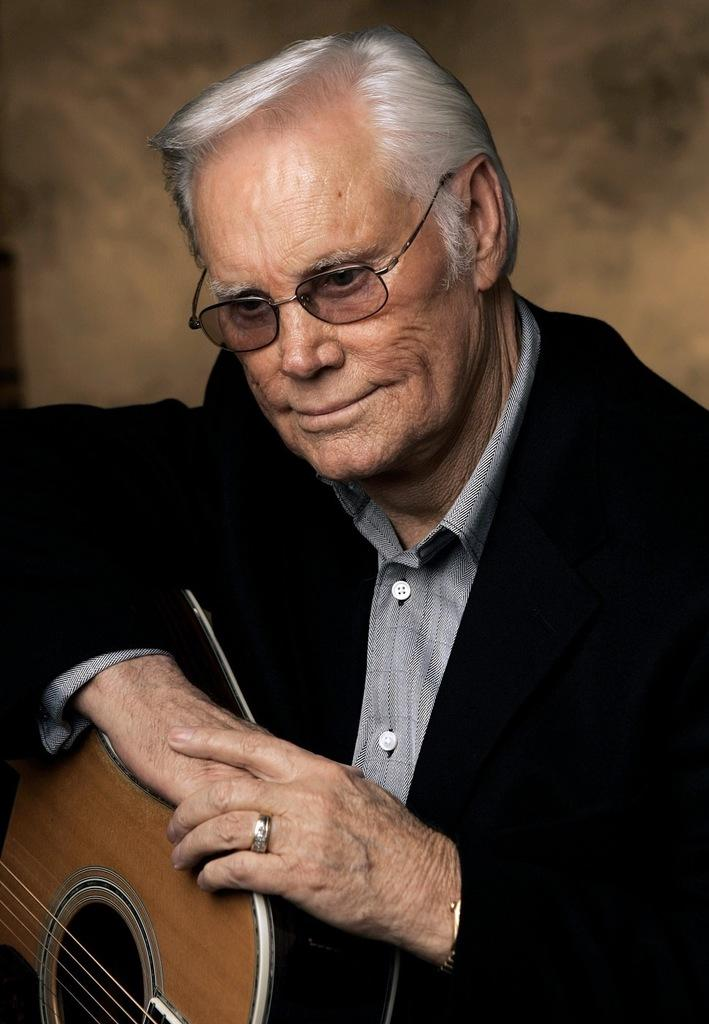What is the main subject of the image? The main subject of the image is a man. What is the man doing in the image? The man is sitting in the image. What object is the man holding in his hand? The man is holding a guitar in his hand. What type of canvas is the man painting in the image? There is no canvas present in the image, nor is the man painting. 